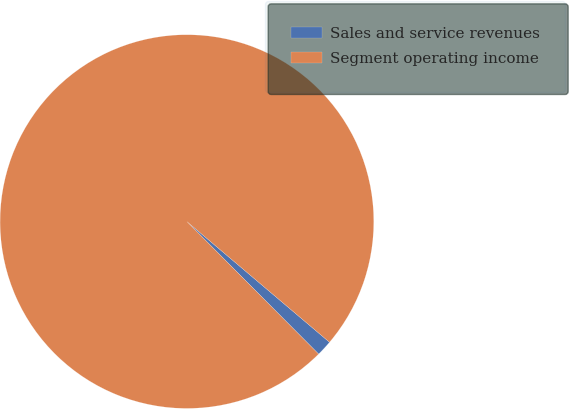<chart> <loc_0><loc_0><loc_500><loc_500><pie_chart><fcel>Sales and service revenues<fcel>Segment operating income<nl><fcel>1.37%<fcel>98.63%<nl></chart> 